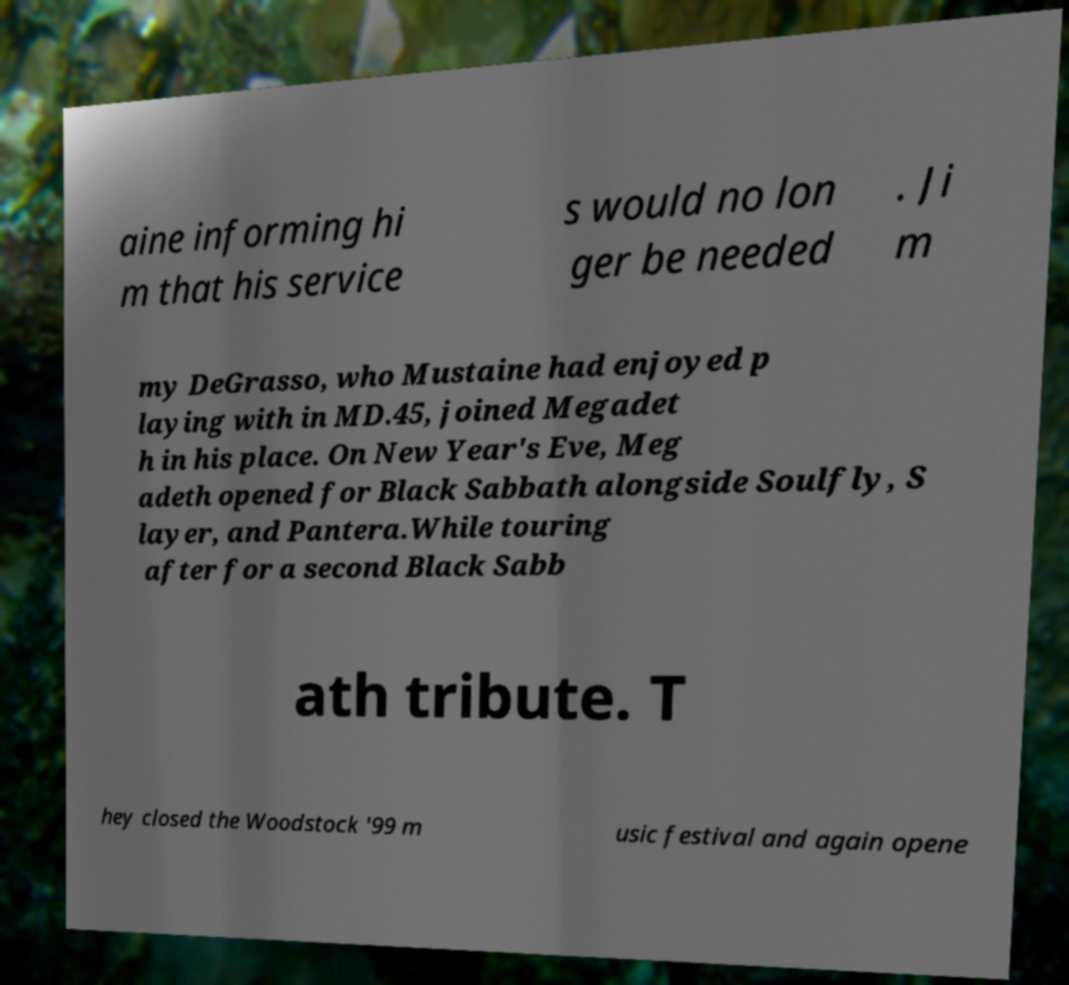Can you read and provide the text displayed in the image?This photo seems to have some interesting text. Can you extract and type it out for me? aine informing hi m that his service s would no lon ger be needed . Ji m my DeGrasso, who Mustaine had enjoyed p laying with in MD.45, joined Megadet h in his place. On New Year's Eve, Meg adeth opened for Black Sabbath alongside Soulfly, S layer, and Pantera.While touring after for a second Black Sabb ath tribute. T hey closed the Woodstock '99 m usic festival and again opene 